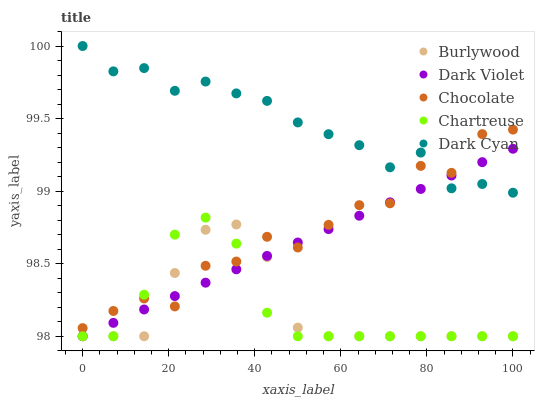Does Burlywood have the minimum area under the curve?
Answer yes or no. Yes. Does Dark Cyan have the maximum area under the curve?
Answer yes or no. Yes. Does Chartreuse have the minimum area under the curve?
Answer yes or no. No. Does Chartreuse have the maximum area under the curve?
Answer yes or no. No. Is Dark Violet the smoothest?
Answer yes or no. Yes. Is Chocolate the roughest?
Answer yes or no. Yes. Is Dark Cyan the smoothest?
Answer yes or no. No. Is Dark Cyan the roughest?
Answer yes or no. No. Does Burlywood have the lowest value?
Answer yes or no. Yes. Does Dark Cyan have the lowest value?
Answer yes or no. No. Does Dark Cyan have the highest value?
Answer yes or no. Yes. Does Chartreuse have the highest value?
Answer yes or no. No. Is Burlywood less than Dark Cyan?
Answer yes or no. Yes. Is Dark Cyan greater than Chartreuse?
Answer yes or no. Yes. Does Chocolate intersect Burlywood?
Answer yes or no. Yes. Is Chocolate less than Burlywood?
Answer yes or no. No. Is Chocolate greater than Burlywood?
Answer yes or no. No. Does Burlywood intersect Dark Cyan?
Answer yes or no. No. 